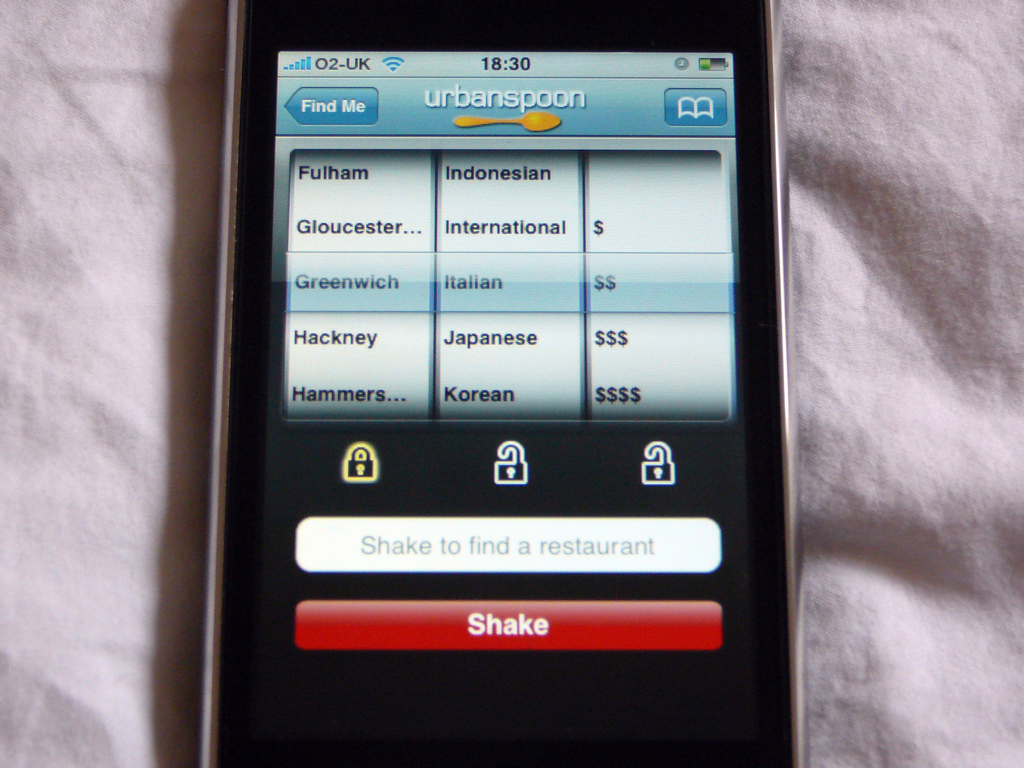What do the different dollar sign categories signify in this context? In the Urbanspoon app, the dollar sign categories represent different price ranges for restaurants. A single dollar sign ($) indicates a more affordable dining option, whereas multiple dollar signs (e.g., $$$) suggest a higher-end, more expensive restaurant. This system helps users quickly ascertain the cost level of a restaurant, aiding in making a decision that fits their budget preferences. 